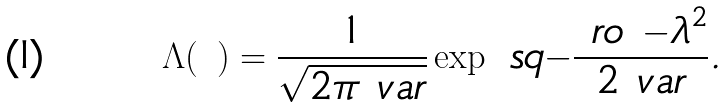<formula> <loc_0><loc_0><loc_500><loc_500>\Lambda ( \ ) = \frac { 1 } { \sqrt { 2 \pi \ v a r } } \exp \ s q { - \frac { \ r o { \ - \lambda } ^ { 2 } } { 2 \ v a r } } .</formula> 